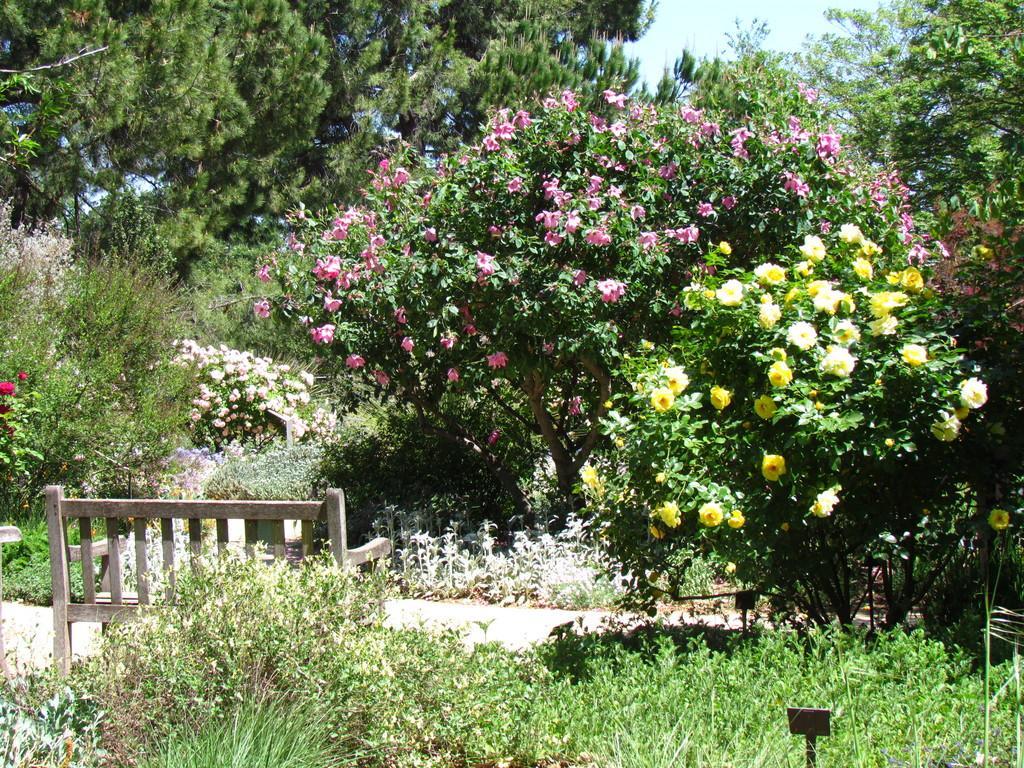Can you describe this image briefly? In this image we can see few plants, trees, a bench, few trees with flowers, and the sky in the background. 